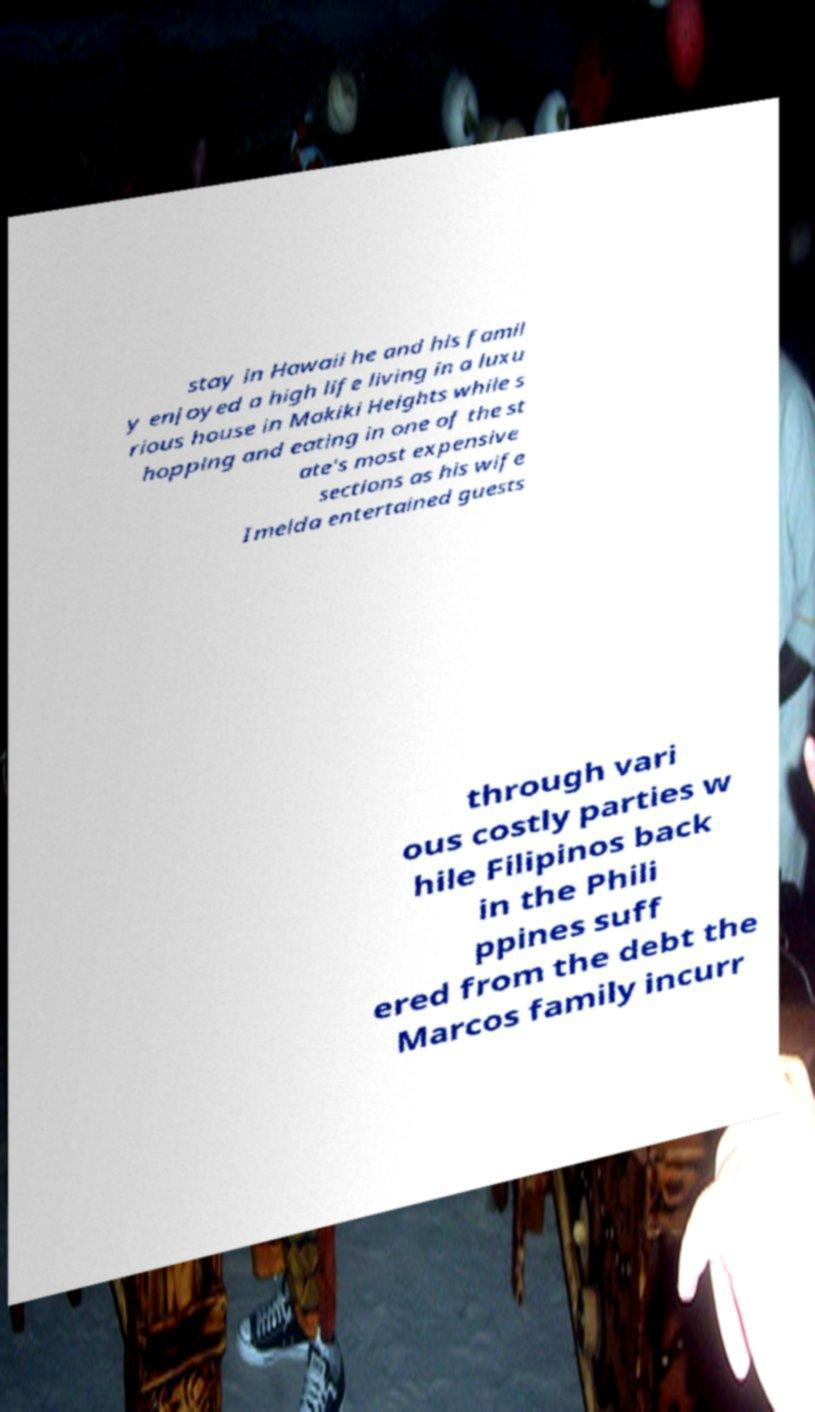Can you accurately transcribe the text from the provided image for me? stay in Hawaii he and his famil y enjoyed a high life living in a luxu rious house in Makiki Heights while s hopping and eating in one of the st ate's most expensive sections as his wife Imelda entertained guests through vari ous costly parties w hile Filipinos back in the Phili ppines suff ered from the debt the Marcos family incurr 